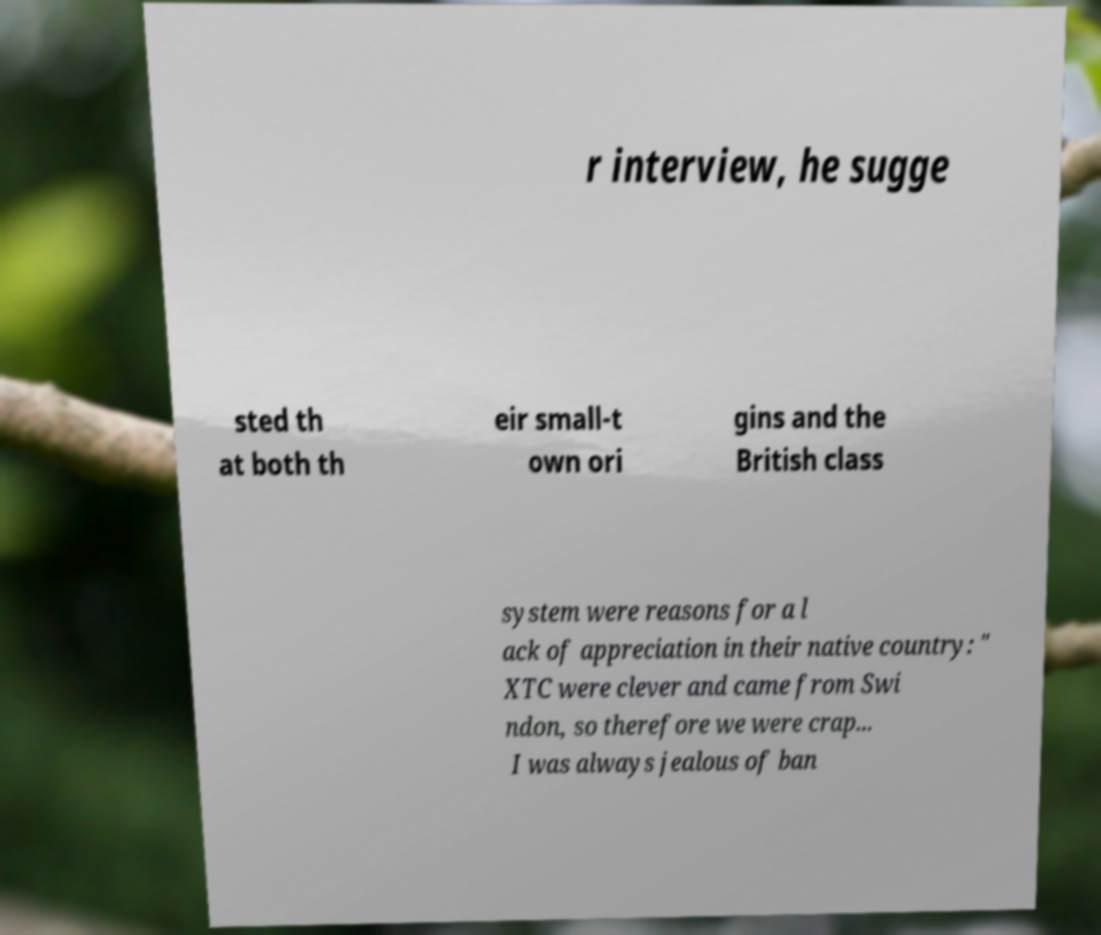Please read and relay the text visible in this image. What does it say? r interview, he sugge sted th at both th eir small-t own ori gins and the British class system were reasons for a l ack of appreciation in their native country: " XTC were clever and came from Swi ndon, so therefore we were crap... I was always jealous of ban 